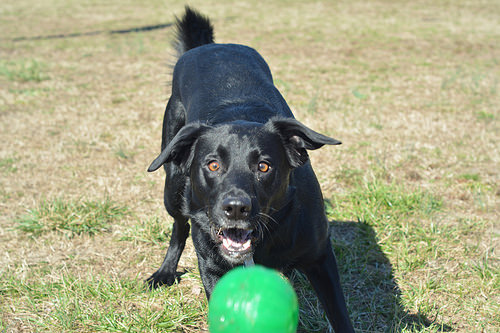<image>
Can you confirm if the dog is behind the ball? Yes. From this viewpoint, the dog is positioned behind the ball, with the ball partially or fully occluding the dog. Where is the dog in relation to the ball? Is it in front of the ball? No. The dog is not in front of the ball. The spatial positioning shows a different relationship between these objects. 